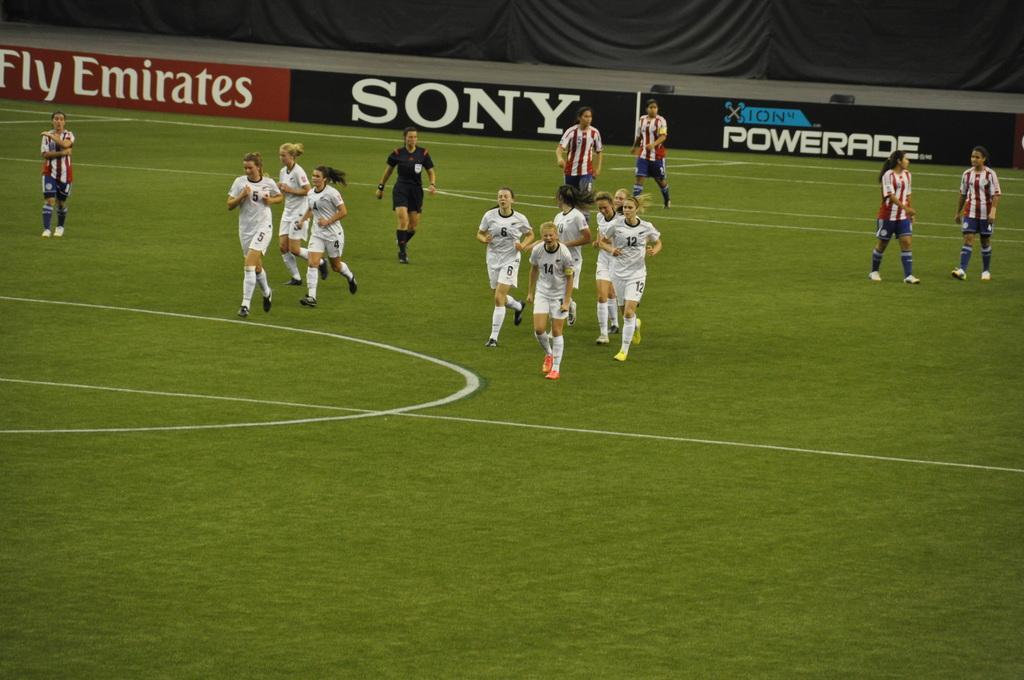How would you summarize this image in a sentence or two? In the image we can see there are people standing on the ground and the ground is covered with grass. Behind there is a banner fencing. 